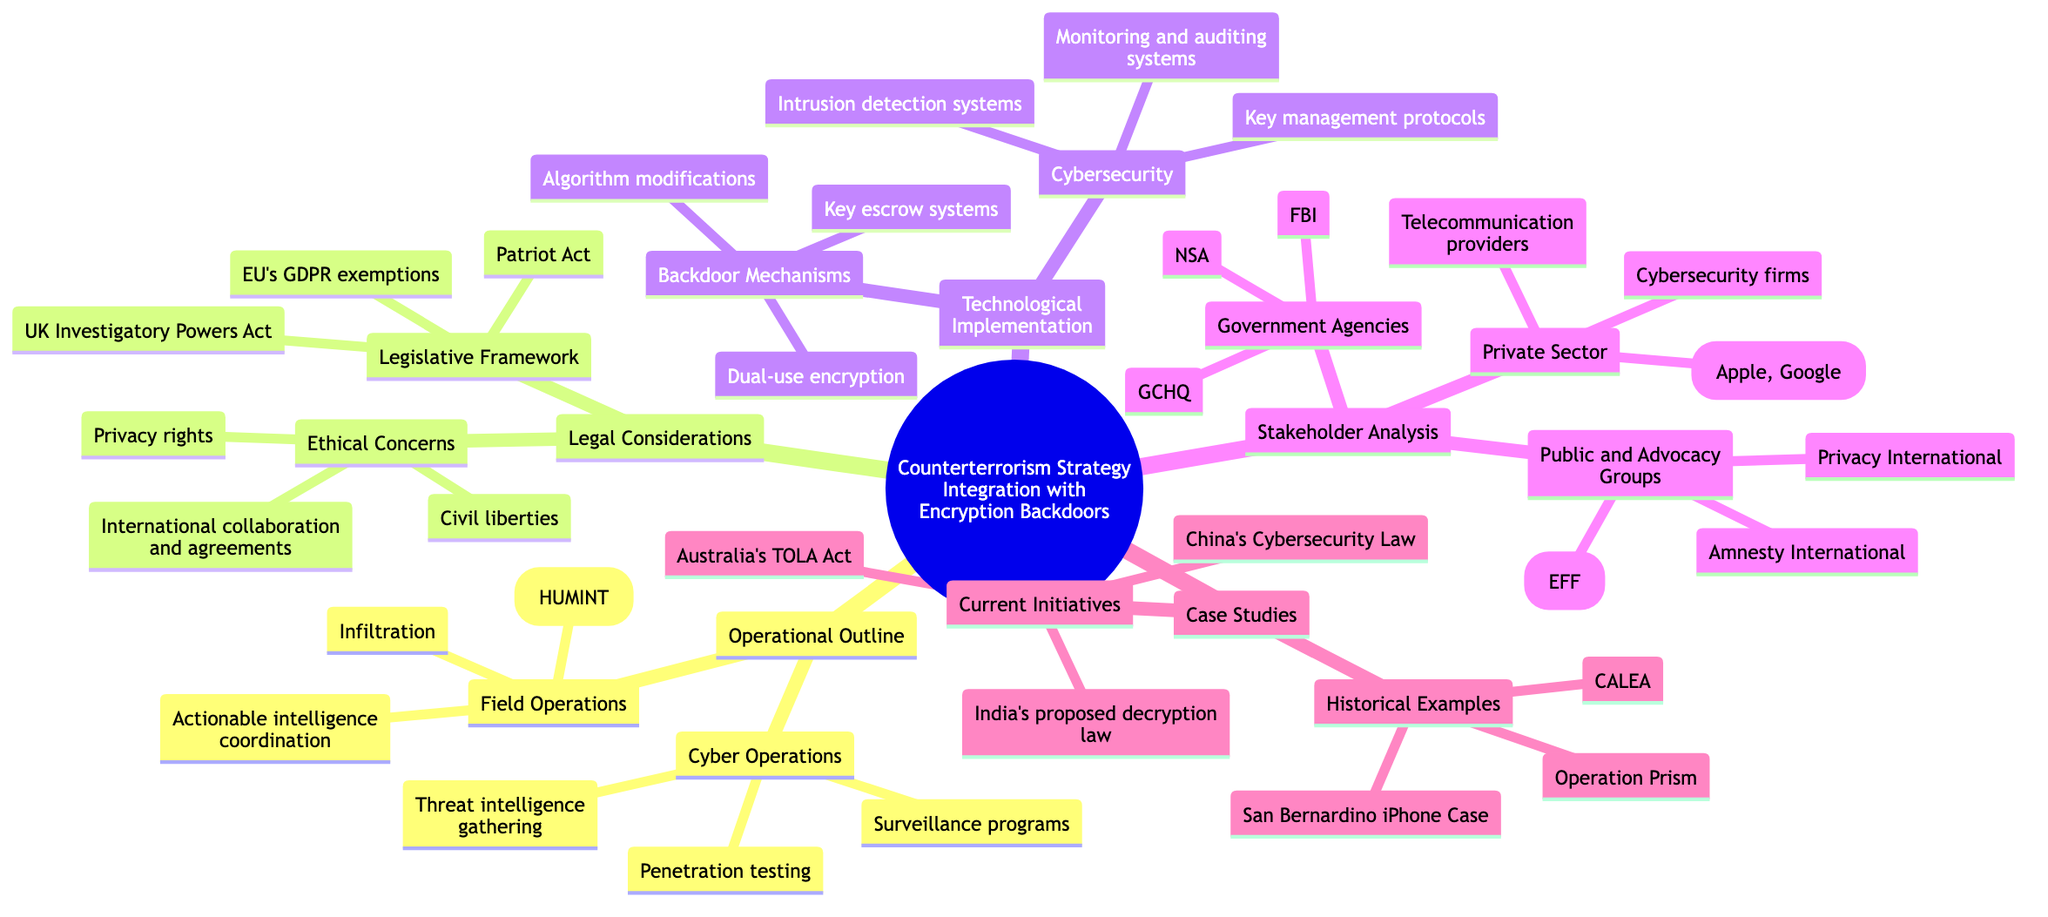What are two categories under Operational Outline? The diagram shows "Cyber Operations" and "Field Operations" as two main subcategories under "Operational Outline." Each of these categories further details specific elements related to counterterrorism strategy.
Answer: Cyber Operations, Field Operations How many backdoor mechanisms are listed? The section "Backdoor Mechanisms" contains three specific elements: "Key escrow systems," "Dual-use encryption," and "Algorithm modifications." Thus, the total count of backdoor mechanisms listed is three.
Answer: 3 Which legislative framework is mentioned first? The first legislative framework mentioned in "Legal Considerations" is the "Patriot Act." As this is the first item listed in that category, it is straightforward to identify.
Answer: Patriot Act What is one of the ethical concerns highlighted in the diagram? The diagram states "Privacy rights" as one of the ethical concerns under "Legal Considerations." This indicates a dilemma in balancing security with citizens' privacy.
Answer: Privacy rights Name a current initiative related to encryption backdoors. The diagram identifies "Australia's Telecommunications and Other Legislation Amendment (TOLA) Act" as one of the current initiatives. It specifically addresses contemporary legislative efforts in encryption and surveillance.
Answer: Australia's TOLA Act Which government agency is listed under Stakeholder Analysis? The "Stakeholder Analysis" includes "NSA" as one of the government agencies mentioned. This indicates the involvement of significant governmental bodies in counterterrorism related to encryption.
Answer: NSA How many public and advocacy groups are mentioned? The section on "Public and Advocacy Groups" lists three organizations: "Electronic Frontier Foundation (EFF)," "Amnesty International," and "Privacy International." Therefore, there are three groups mentioned.
Answer: 3 What do "Penetration testing" and "Surveillance programs" fall under? Both "Penetration testing" and "Surveillance programs" are categorized under "Cyber Operations." This indicates their role within the operational framework for counterterrorism efforts.
Answer: Cyber Operations Which case study involves a significant iPhone security issue? The "San Bernardino iPhone Case" is specifically noted as a historical example that illustrates challenges related to encryption in law enforcement efforts.
Answer: San Bernardino iPhone Case 